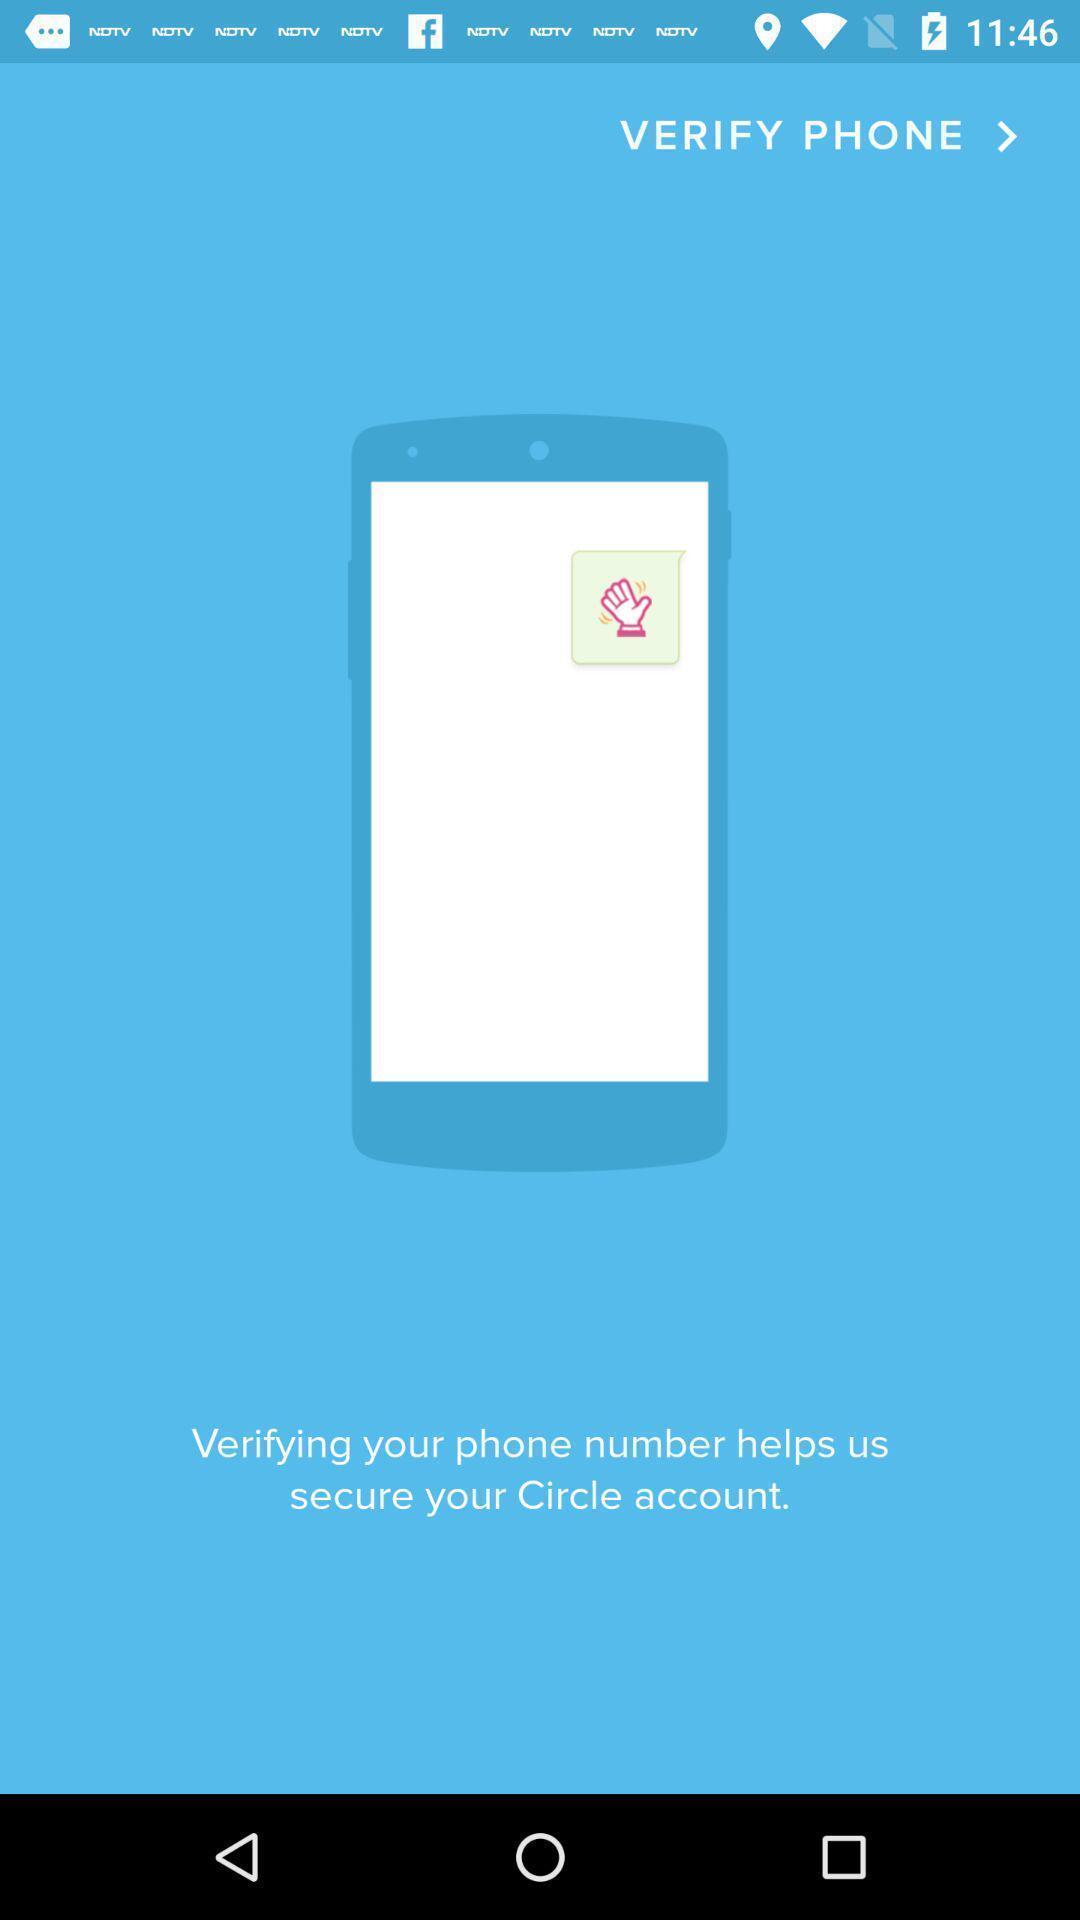Explain what's happening in this screen capture. Page showing verify your phone number. 